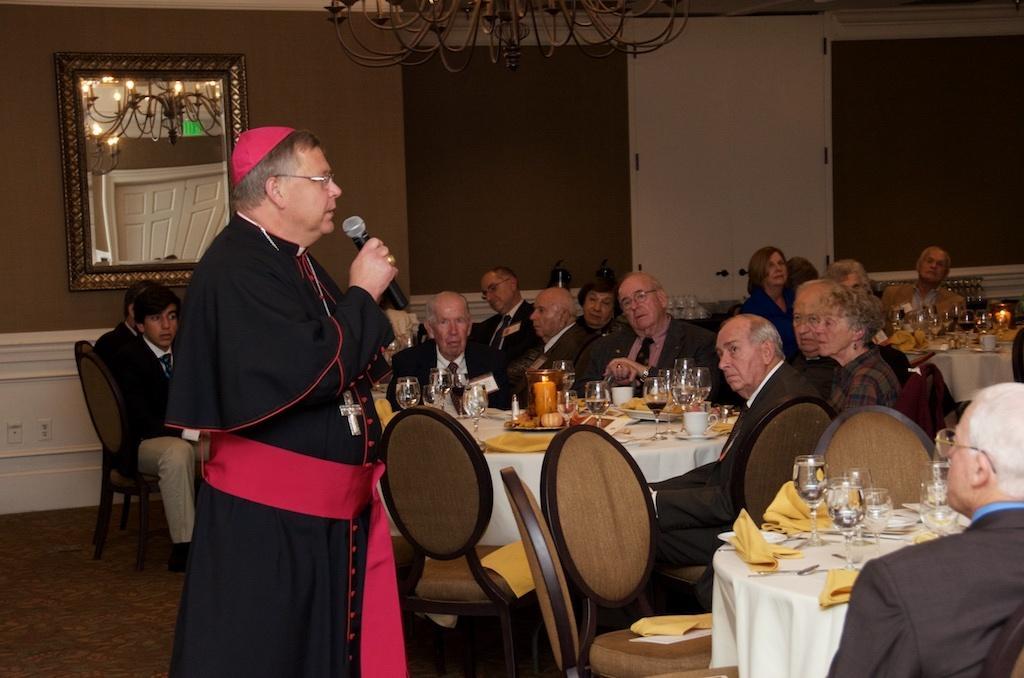Describe this image in one or two sentences. In this picture we can observe a person standing, wearing black color dress and holding a mic in his hand. There are some people sitting in the chairs around the table, wearing coats. We can observe some glasses and food items placed on the table. In the background we can observe a mirror and a wall. 